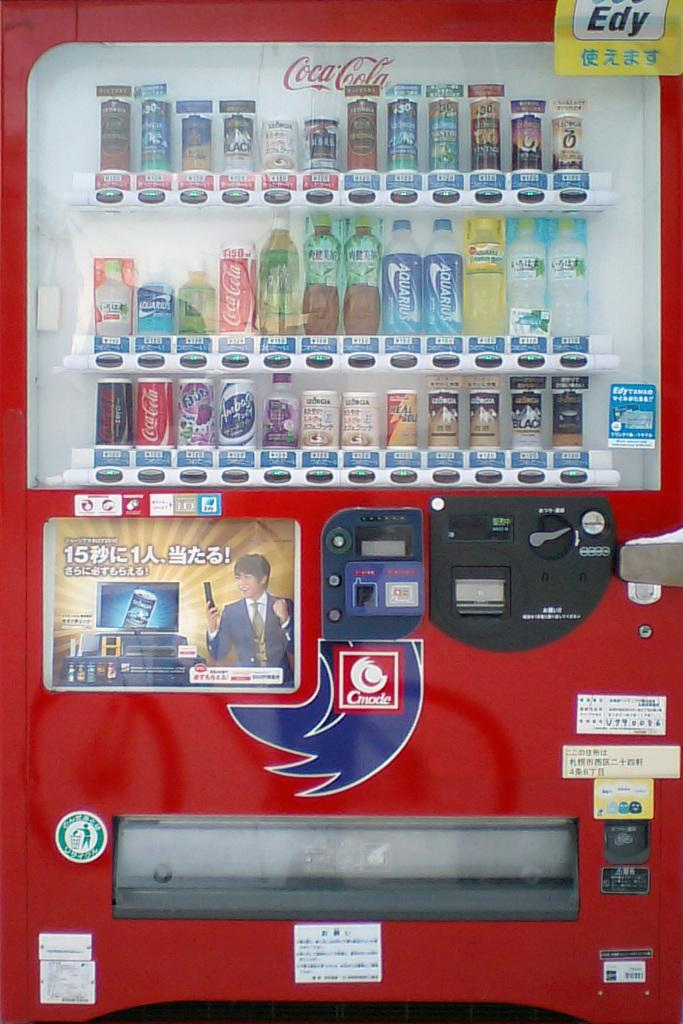<image>
Share a concise interpretation of the image provided. A red vending machine has Coca Cola for sale. 